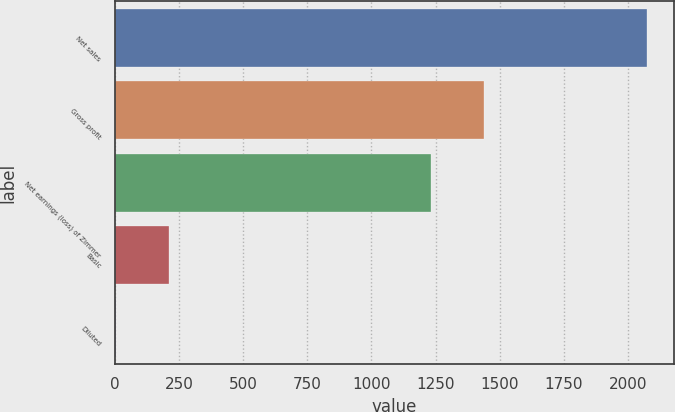Convert chart. <chart><loc_0><loc_0><loc_500><loc_500><bar_chart><fcel>Net sales<fcel>Gross profit<fcel>Net earnings (loss) of Zimmer<fcel>Basic<fcel>Diluted<nl><fcel>2074.3<fcel>1438.23<fcel>1231.4<fcel>212.86<fcel>6.03<nl></chart> 